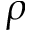<formula> <loc_0><loc_0><loc_500><loc_500>\rho</formula> 